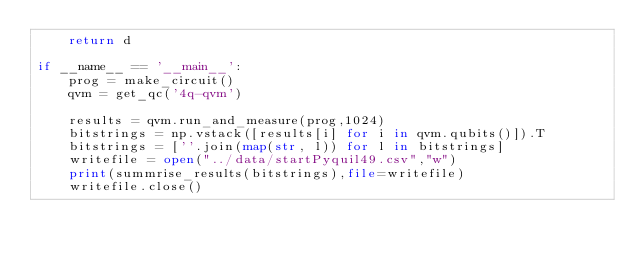Convert code to text. <code><loc_0><loc_0><loc_500><loc_500><_Python_>    return d

if __name__ == '__main__':
    prog = make_circuit()
    qvm = get_qc('4q-qvm')

    results = qvm.run_and_measure(prog,1024)
    bitstrings = np.vstack([results[i] for i in qvm.qubits()]).T
    bitstrings = [''.join(map(str, l)) for l in bitstrings]
    writefile = open("../data/startPyquil49.csv","w")
    print(summrise_results(bitstrings),file=writefile)
    writefile.close()

</code> 